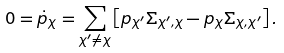Convert formula to latex. <formula><loc_0><loc_0><loc_500><loc_500>0 = \dot { p } _ { \chi } = \sum _ { \chi ^ { \prime } \neq \chi } \left [ p _ { \chi ^ { \prime } } \Sigma _ { \chi ^ { \prime } , \chi } - p _ { \chi } \Sigma _ { \chi , \chi ^ { \prime } } \right ] .</formula> 